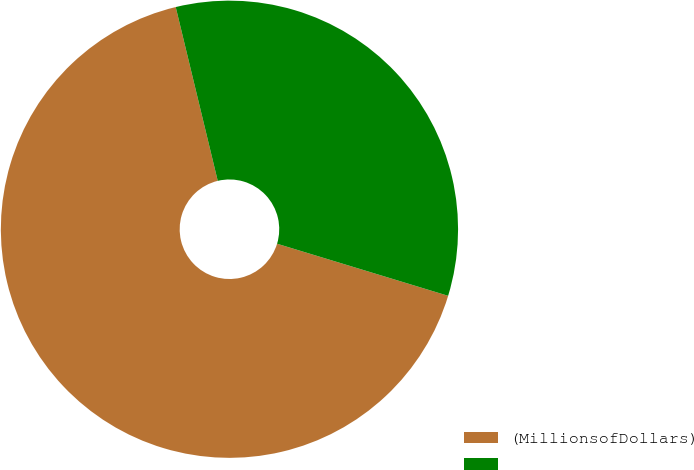Convert chart to OTSL. <chart><loc_0><loc_0><loc_500><loc_500><pie_chart><fcel>(MillionsofDollars)<fcel>Unnamed: 1<nl><fcel>66.52%<fcel>33.48%<nl></chart> 